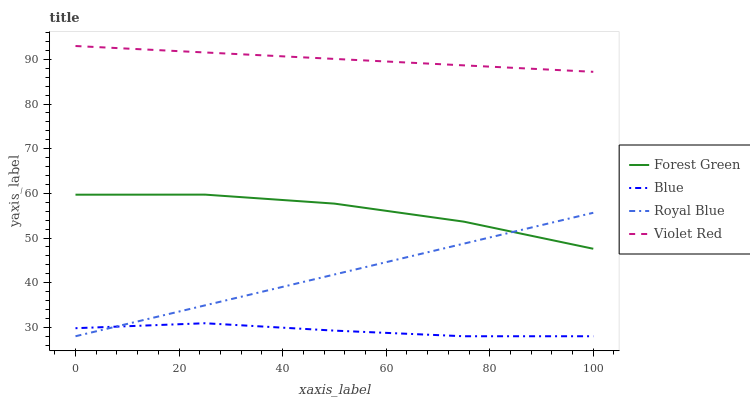Does Blue have the minimum area under the curve?
Answer yes or no. Yes. Does Violet Red have the maximum area under the curve?
Answer yes or no. Yes. Does Royal Blue have the minimum area under the curve?
Answer yes or no. No. Does Royal Blue have the maximum area under the curve?
Answer yes or no. No. Is Royal Blue the smoothest?
Answer yes or no. Yes. Is Forest Green the roughest?
Answer yes or no. Yes. Is Forest Green the smoothest?
Answer yes or no. No. Is Royal Blue the roughest?
Answer yes or no. No. Does Blue have the lowest value?
Answer yes or no. Yes. Does Forest Green have the lowest value?
Answer yes or no. No. Does Violet Red have the highest value?
Answer yes or no. Yes. Does Royal Blue have the highest value?
Answer yes or no. No. Is Blue less than Forest Green?
Answer yes or no. Yes. Is Violet Red greater than Blue?
Answer yes or no. Yes. Does Royal Blue intersect Forest Green?
Answer yes or no. Yes. Is Royal Blue less than Forest Green?
Answer yes or no. No. Is Royal Blue greater than Forest Green?
Answer yes or no. No. Does Blue intersect Forest Green?
Answer yes or no. No. 